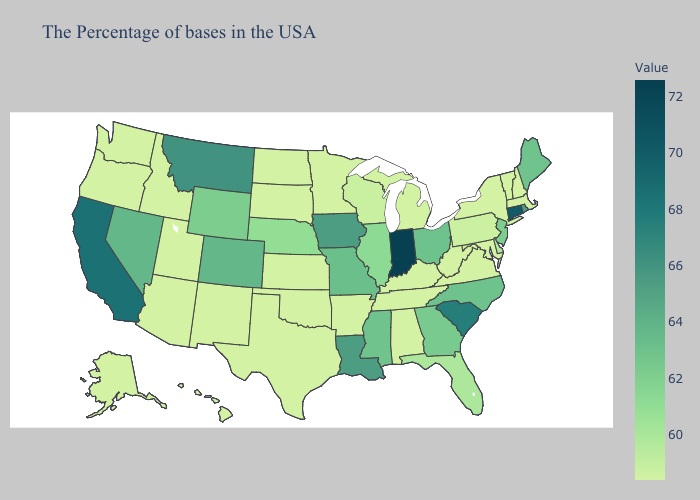Does Alaska have the highest value in the USA?
Give a very brief answer. No. Does South Dakota have the lowest value in the MidWest?
Concise answer only. Yes. Which states have the lowest value in the Northeast?
Give a very brief answer. Massachusetts, New Hampshire, Vermont, New York. Is the legend a continuous bar?
Quick response, please. Yes. Is the legend a continuous bar?
Keep it brief. Yes. 